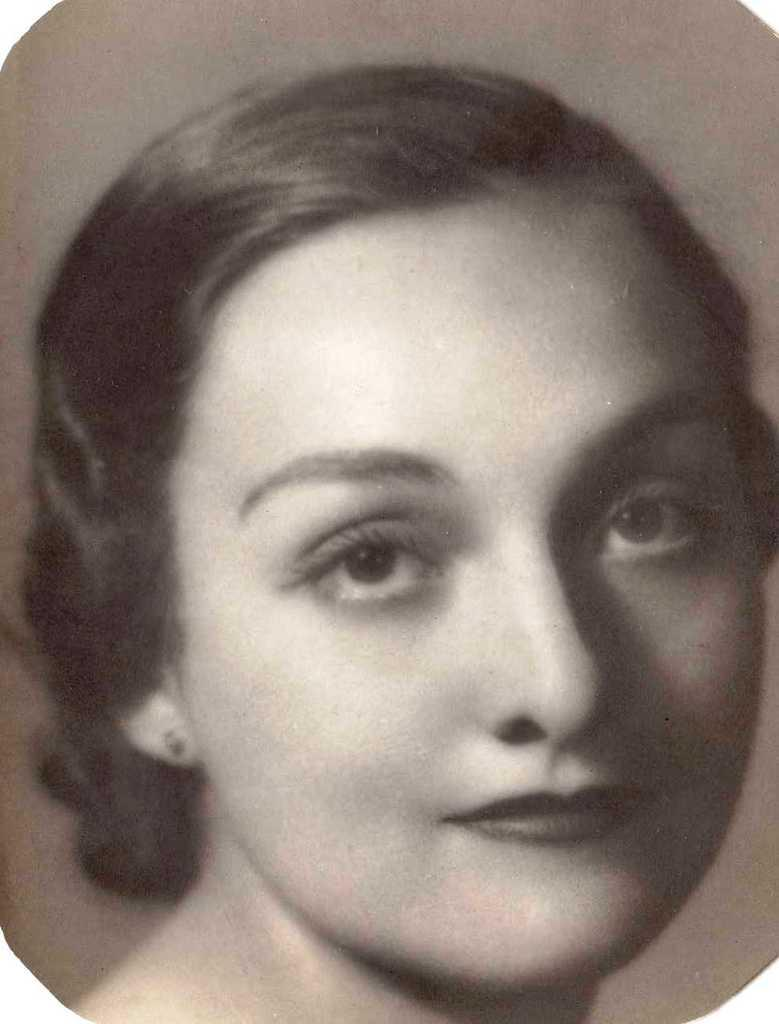Who is the main subject in the image? There is a lady in the image. What color is the background of the image? The background of the image is white. What type of education does the lady have in the morning? There is no information about the lady's education or the time of day in the image, so it cannot be determined from the image. 